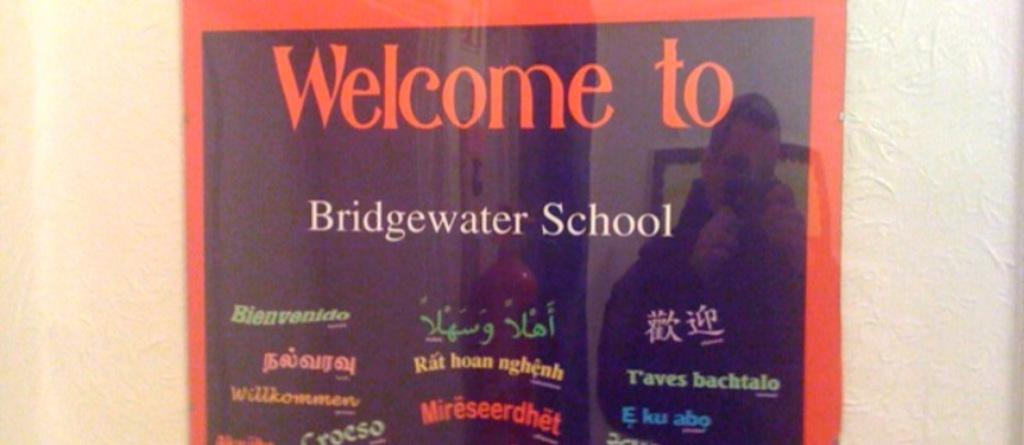<image>
Offer a succinct explanation of the picture presented. A poster that says "Welcome to Bridgewater School." 